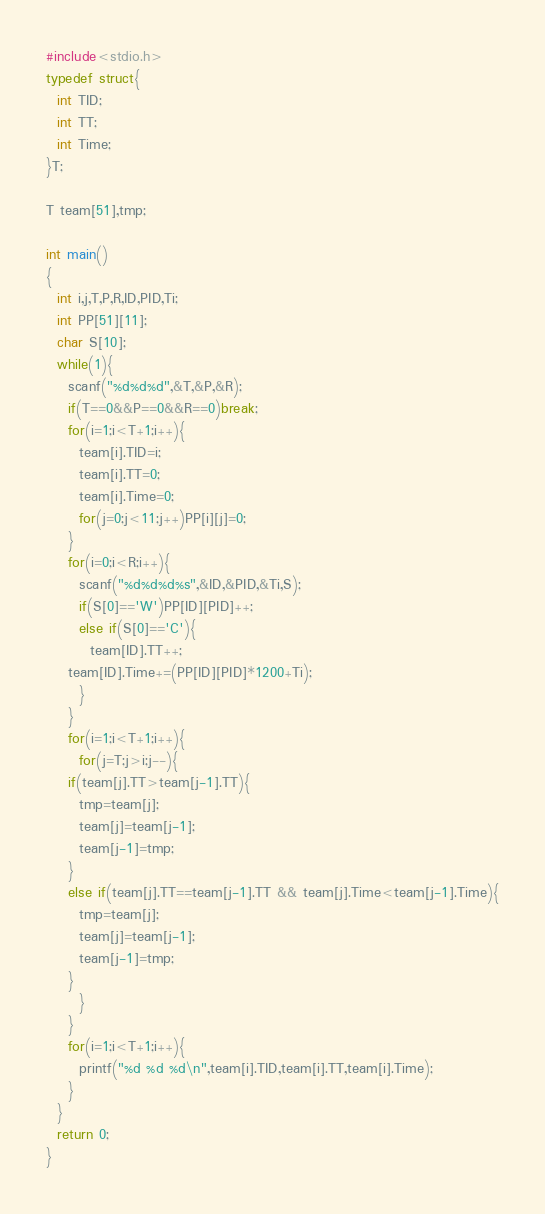<code> <loc_0><loc_0><loc_500><loc_500><_C_>#include<stdio.h>
typedef struct{
  int TID;
  int TT;
  int Time;
}T;

T team[51],tmp;

int main()
{
  int i,j,T,P,R,ID,PID,Ti;
  int PP[51][11];
  char S[10];
  while(1){
    scanf("%d%d%d",&T,&P,&R);
    if(T==0&&P==0&&R==0)break;
    for(i=1;i<T+1;i++){
      team[i].TID=i;
      team[i].TT=0;
      team[i].Time=0;
      for(j=0;j<11;j++)PP[i][j]=0;
    }
    for(i=0;i<R;i++){
      scanf("%d%d%d%s",&ID,&PID,&Ti,S);
      if(S[0]=='W')PP[ID][PID]++;
      else if(S[0]=='C'){
        team[ID].TT++;
	team[ID].Time+=(PP[ID][PID]*1200+Ti);
      }
    }
    for(i=1;i<T+1;i++){
      for(j=T;j>i;j--){
	if(team[j].TT>team[j-1].TT){
	  tmp=team[j];
	  team[j]=team[j-1];
	  team[j-1]=tmp;
	}
	else if(team[j].TT==team[j-1].TT && team[j].Time<team[j-1].Time){
	  tmp=team[j];
	  team[j]=team[j-1];
	  team[j-1]=tmp;
	}
      }
    }
    for(i=1;i<T+1;i++){
      printf("%d %d %d\n",team[i].TID,team[i].TT,team[i].Time);
    }
  }
  return 0;
}</code> 